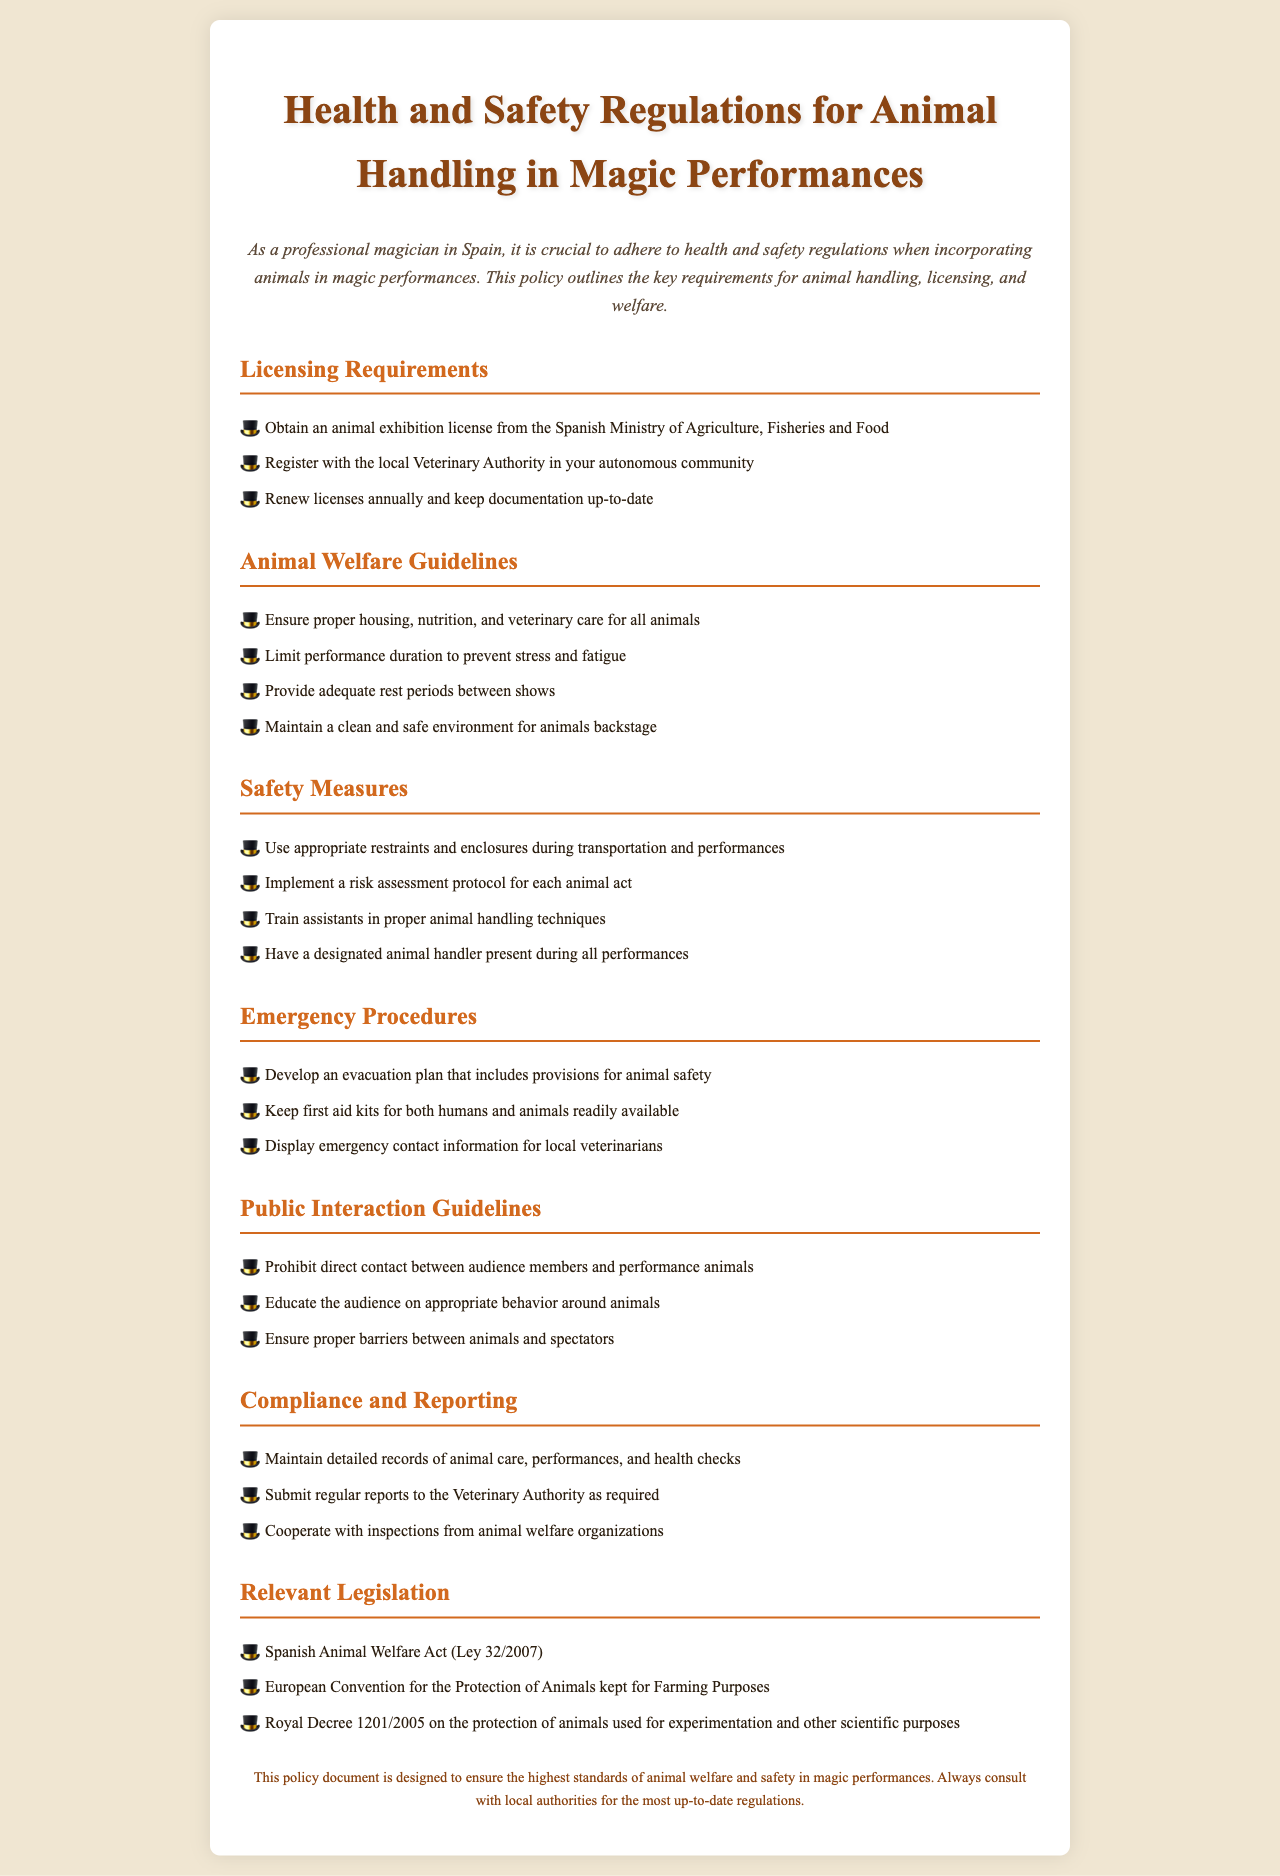What is required to obtain an animal exhibition license? The document states that one must obtain an animal exhibition license from the Spanish Ministry of Agriculture, Fisheries and Food.
Answer: animal exhibition license from the Spanish Ministry of Agriculture, Fisheries and Food How often should licenses be renewed? According to the licensing requirements, licenses must be renewed annually.
Answer: annually What should be provided between shows? The animal welfare guidelines specify that adequate rest periods should be provided between shows.
Answer: adequate rest periods Who should present during all performances? The safety measures indicate that a designated animal handler should be present during all performances.
Answer: designated animal handler What act governs animal welfare in Spain? The relevant legislation mentions the Spanish Animal Welfare Act (Ley 32/2007).
Answer: Spanish Animal Welfare Act (Ley 32/2007) What type of contact with performance animals is prohibited? The public interaction guidelines state that direct contact between audience members and performance animals is prohibited.
Answer: direct contact What must be maintained for compliance? The document outlines that detailed records of animal care, performances, and health checks must be maintained for compliance.
Answer: detailed records of animal care, performances, and health checks What should be available for emergencies? The emergency procedures highlight the need for first aid kits for both humans and animals to be readily available.
Answer: first aid kits for both humans and animals What is the maximum duration limit for performance? The document mentions limiting performance duration to prevent stress and fatigue, but does not specify a maximum time.
Answer: prevents stress and fatigue 